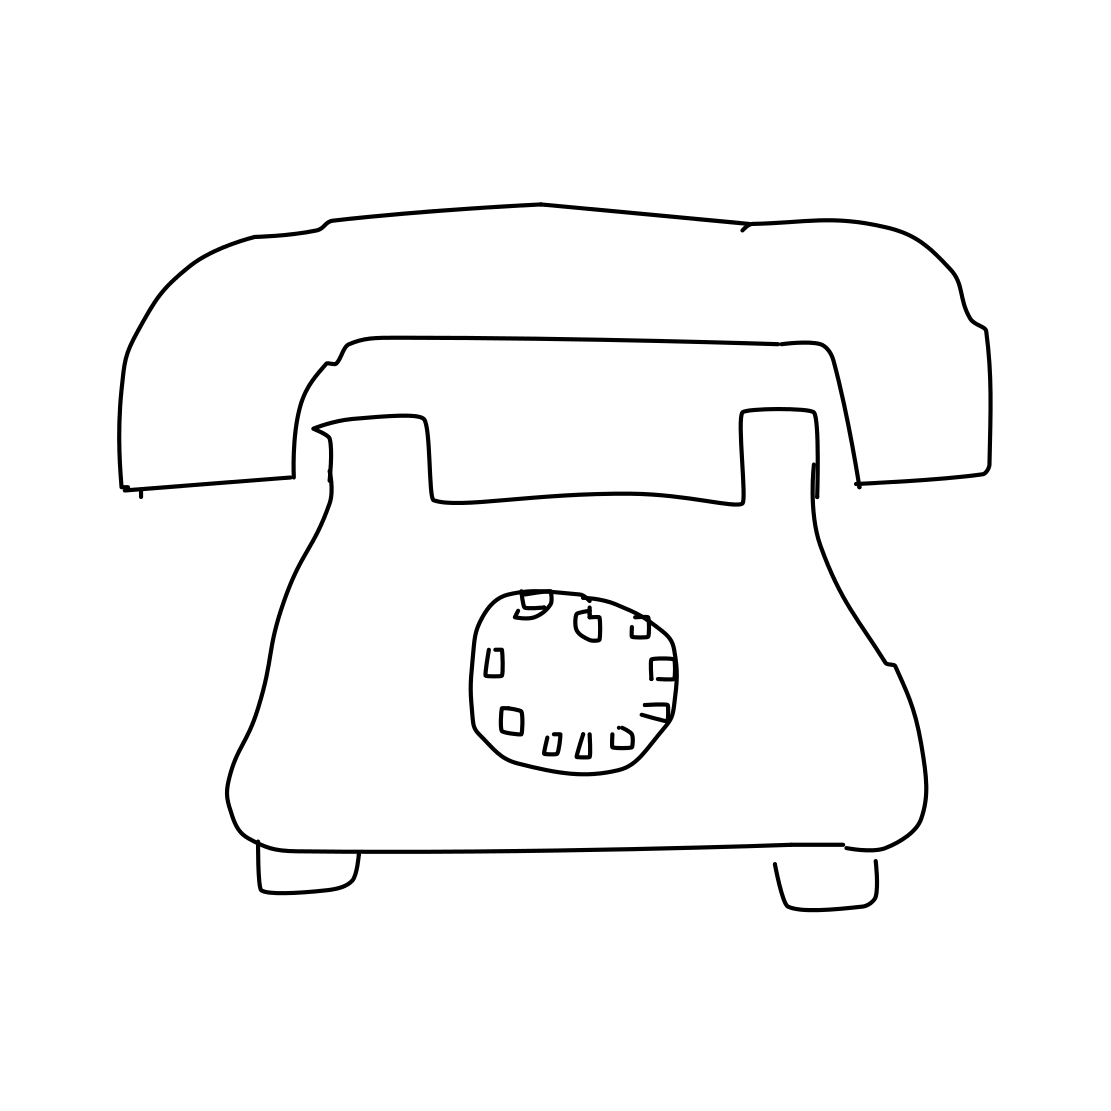Is this a tv in the image? No 